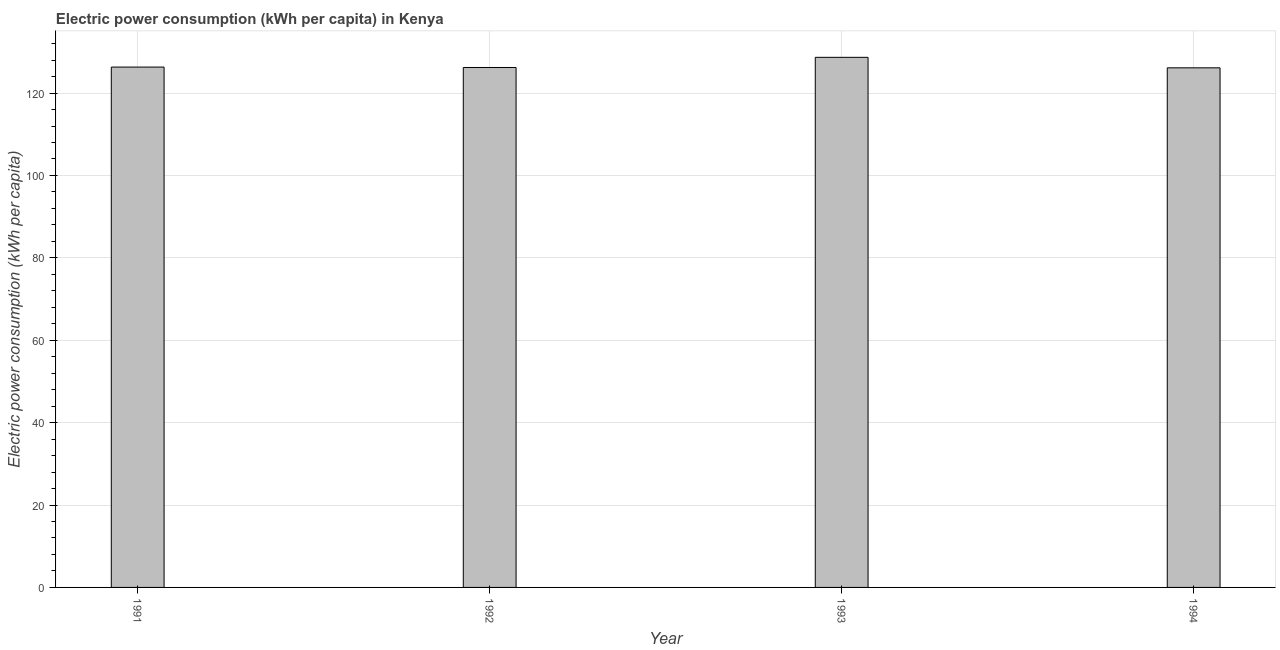Does the graph contain any zero values?
Offer a terse response. No. What is the title of the graph?
Provide a succinct answer. Electric power consumption (kWh per capita) in Kenya. What is the label or title of the X-axis?
Keep it short and to the point. Year. What is the label or title of the Y-axis?
Offer a very short reply. Electric power consumption (kWh per capita). What is the electric power consumption in 1994?
Your answer should be compact. 126.13. Across all years, what is the maximum electric power consumption?
Give a very brief answer. 128.68. Across all years, what is the minimum electric power consumption?
Provide a short and direct response. 126.13. In which year was the electric power consumption maximum?
Give a very brief answer. 1993. What is the sum of the electric power consumption?
Provide a short and direct response. 507.32. What is the difference between the electric power consumption in 1991 and 1994?
Your answer should be very brief. 0.18. What is the average electric power consumption per year?
Ensure brevity in your answer.  126.83. What is the median electric power consumption?
Your response must be concise. 126.26. In how many years, is the electric power consumption greater than 72 kWh per capita?
Keep it short and to the point. 4. Do a majority of the years between 1991 and 1994 (inclusive) have electric power consumption greater than 4 kWh per capita?
Your answer should be compact. Yes. Is the difference between the electric power consumption in 1992 and 1993 greater than the difference between any two years?
Keep it short and to the point. No. What is the difference between the highest and the second highest electric power consumption?
Keep it short and to the point. 2.37. Is the sum of the electric power consumption in 1992 and 1993 greater than the maximum electric power consumption across all years?
Provide a short and direct response. Yes. What is the difference between the highest and the lowest electric power consumption?
Provide a succinct answer. 2.55. In how many years, is the electric power consumption greater than the average electric power consumption taken over all years?
Make the answer very short. 1. How many bars are there?
Ensure brevity in your answer.  4. Are all the bars in the graph horizontal?
Your response must be concise. No. How many years are there in the graph?
Your response must be concise. 4. What is the Electric power consumption (kWh per capita) in 1991?
Provide a succinct answer. 126.31. What is the Electric power consumption (kWh per capita) in 1992?
Your answer should be very brief. 126.21. What is the Electric power consumption (kWh per capita) in 1993?
Offer a very short reply. 128.68. What is the Electric power consumption (kWh per capita) in 1994?
Give a very brief answer. 126.13. What is the difference between the Electric power consumption (kWh per capita) in 1991 and 1992?
Your answer should be compact. 0.1. What is the difference between the Electric power consumption (kWh per capita) in 1991 and 1993?
Your answer should be compact. -2.37. What is the difference between the Electric power consumption (kWh per capita) in 1991 and 1994?
Your answer should be compact. 0.18. What is the difference between the Electric power consumption (kWh per capita) in 1992 and 1993?
Your response must be concise. -2.47. What is the difference between the Electric power consumption (kWh per capita) in 1992 and 1994?
Your answer should be compact. 0.08. What is the difference between the Electric power consumption (kWh per capita) in 1993 and 1994?
Ensure brevity in your answer.  2.55. What is the ratio of the Electric power consumption (kWh per capita) in 1991 to that in 1992?
Give a very brief answer. 1. What is the ratio of the Electric power consumption (kWh per capita) in 1991 to that in 1993?
Your answer should be very brief. 0.98. What is the ratio of the Electric power consumption (kWh per capita) in 1991 to that in 1994?
Your answer should be compact. 1. What is the ratio of the Electric power consumption (kWh per capita) in 1992 to that in 1994?
Your answer should be compact. 1. 